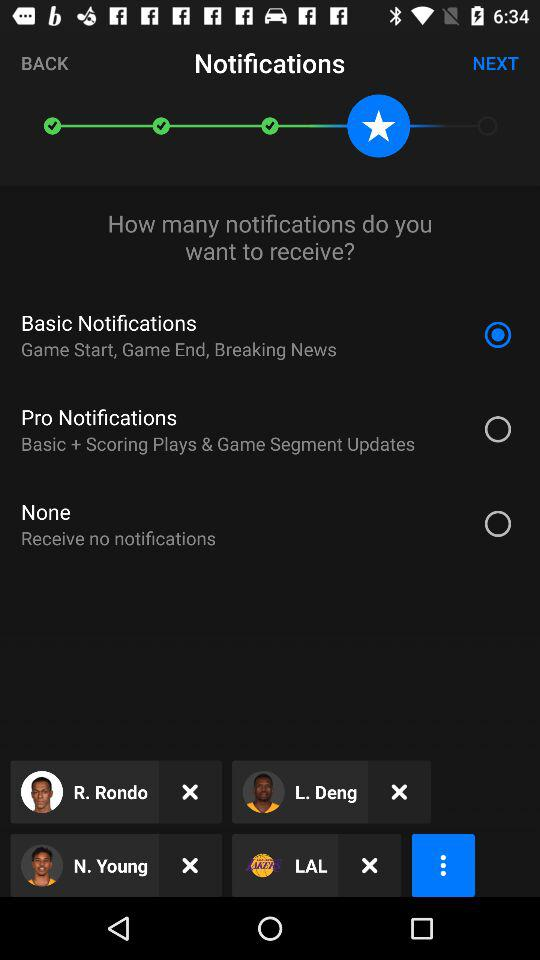What is the description of "Pro Notifications"? The description is "Basic + Scoring Plays & Game Segment Updates". 